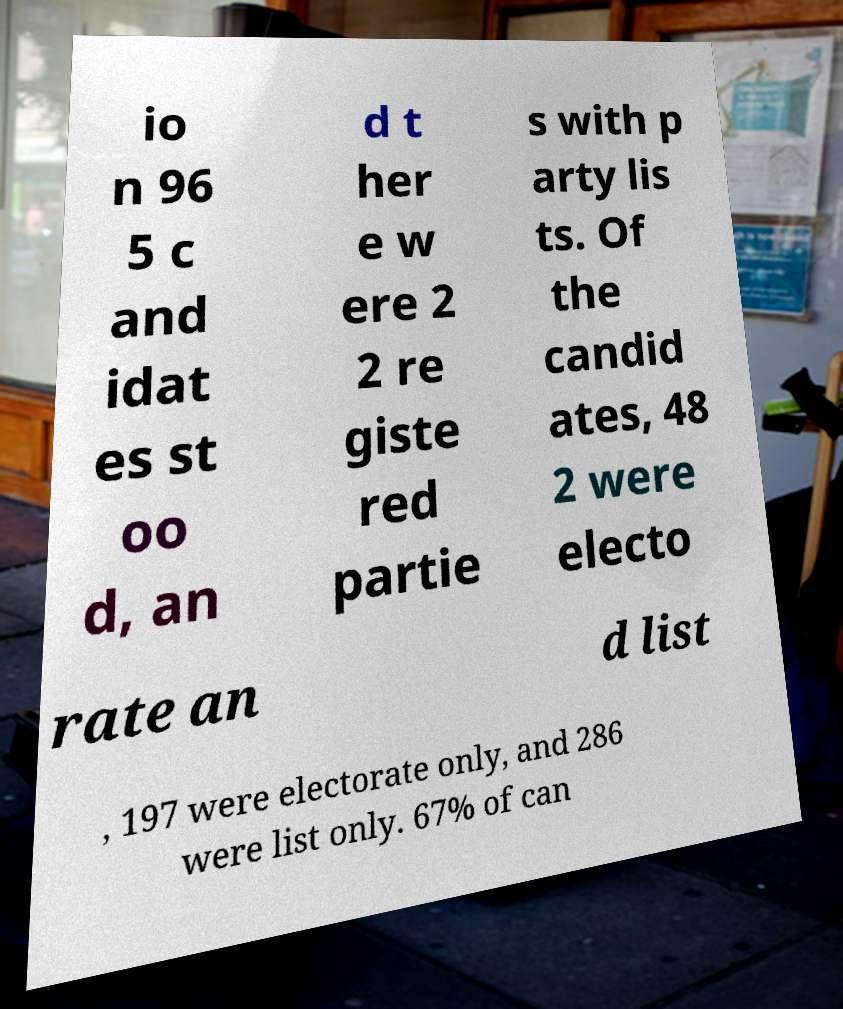Please identify and transcribe the text found in this image. io n 96 5 c and idat es st oo d, an d t her e w ere 2 2 re giste red partie s with p arty lis ts. Of the candid ates, 48 2 were electo rate an d list , 197 were electorate only, and 286 were list only. 67% of can 